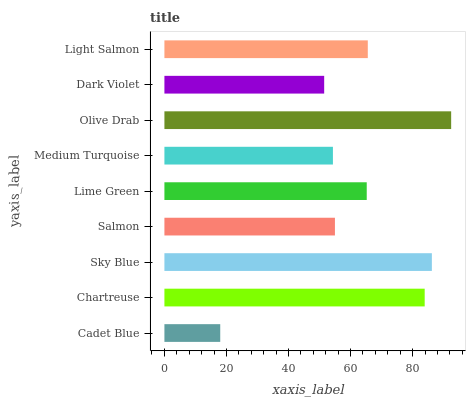Is Cadet Blue the minimum?
Answer yes or no. Yes. Is Olive Drab the maximum?
Answer yes or no. Yes. Is Chartreuse the minimum?
Answer yes or no. No. Is Chartreuse the maximum?
Answer yes or no. No. Is Chartreuse greater than Cadet Blue?
Answer yes or no. Yes. Is Cadet Blue less than Chartreuse?
Answer yes or no. Yes. Is Cadet Blue greater than Chartreuse?
Answer yes or no. No. Is Chartreuse less than Cadet Blue?
Answer yes or no. No. Is Lime Green the high median?
Answer yes or no. Yes. Is Lime Green the low median?
Answer yes or no. Yes. Is Chartreuse the high median?
Answer yes or no. No. Is Cadet Blue the low median?
Answer yes or no. No. 